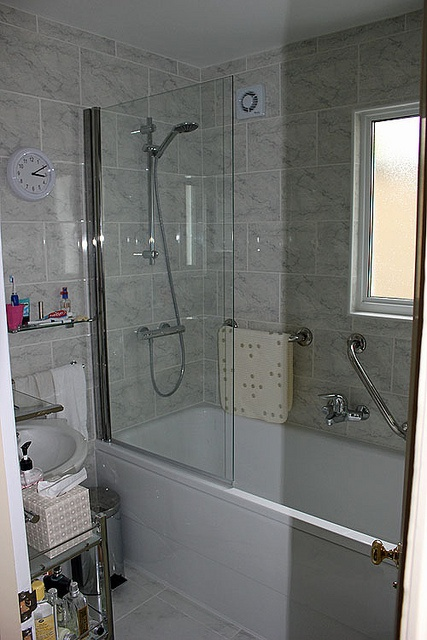Describe the objects in this image and their specific colors. I can see sink in gray and black tones, clock in gray tones, bottle in gray, black, darkgreen, and darkgray tones, bottle in gray, black, darkgray, and darkgreen tones, and bottle in gray, darkgray, and tan tones in this image. 